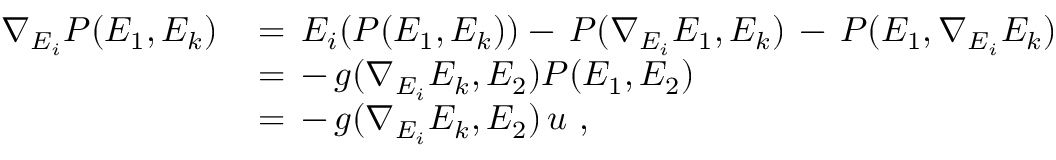<formula> <loc_0><loc_0><loc_500><loc_500>\begin{array} { r l } { \nabla _ { E _ { i } } P ( E _ { 1 } , E _ { k } ) \, } & { = \, E _ { i } ( P ( E _ { 1 } , E _ { k } ) ) - \, P ( \nabla _ { E _ { i } } E _ { 1 } , E _ { k } ) \, - \, P ( E _ { 1 } , \nabla _ { E _ { i } } E _ { k } ) } \\ & { = \, - \, g ( \nabla _ { E _ { i } } E _ { k } , E _ { 2 } ) P ( E _ { 1 } , E _ { 2 } ) } \\ & { = \, - \, g ( \nabla _ { E _ { i } } E _ { k } , E _ { 2 } ) \, u \, , } \end{array}</formula> 